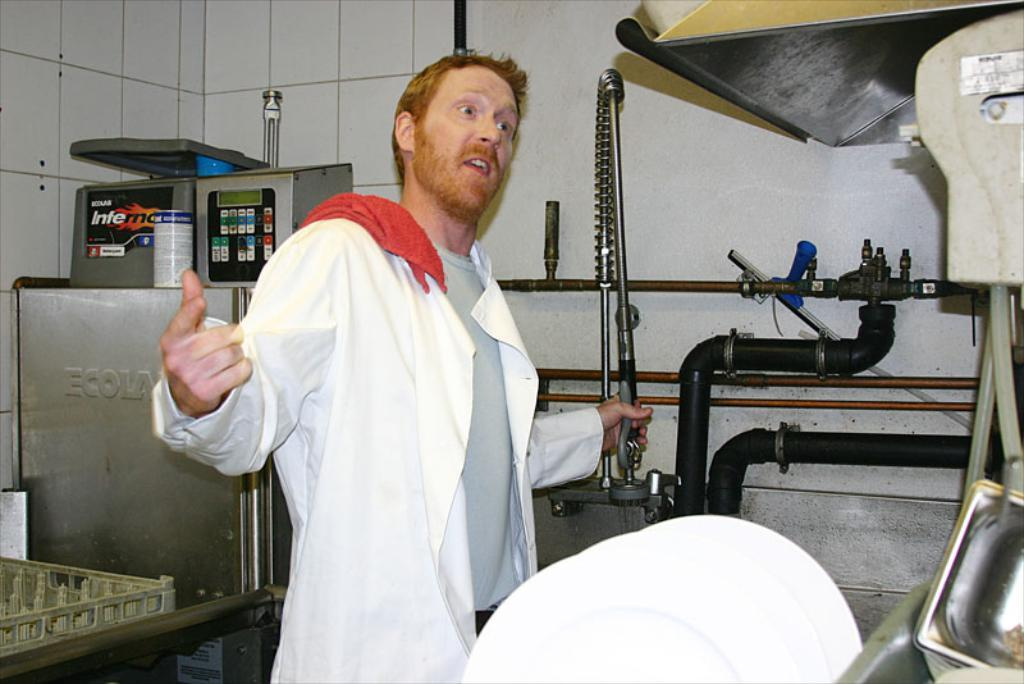What is the man in the image doing? The man is standing in the image. What is the man holding in his hand? The man is holding an object in his hand. What else can be seen in the image besides the man? There are machines and a wall present in the image. Can you hear the man laughing in the image? There is no sound in the image, so it is not possible to hear the man laughing. 